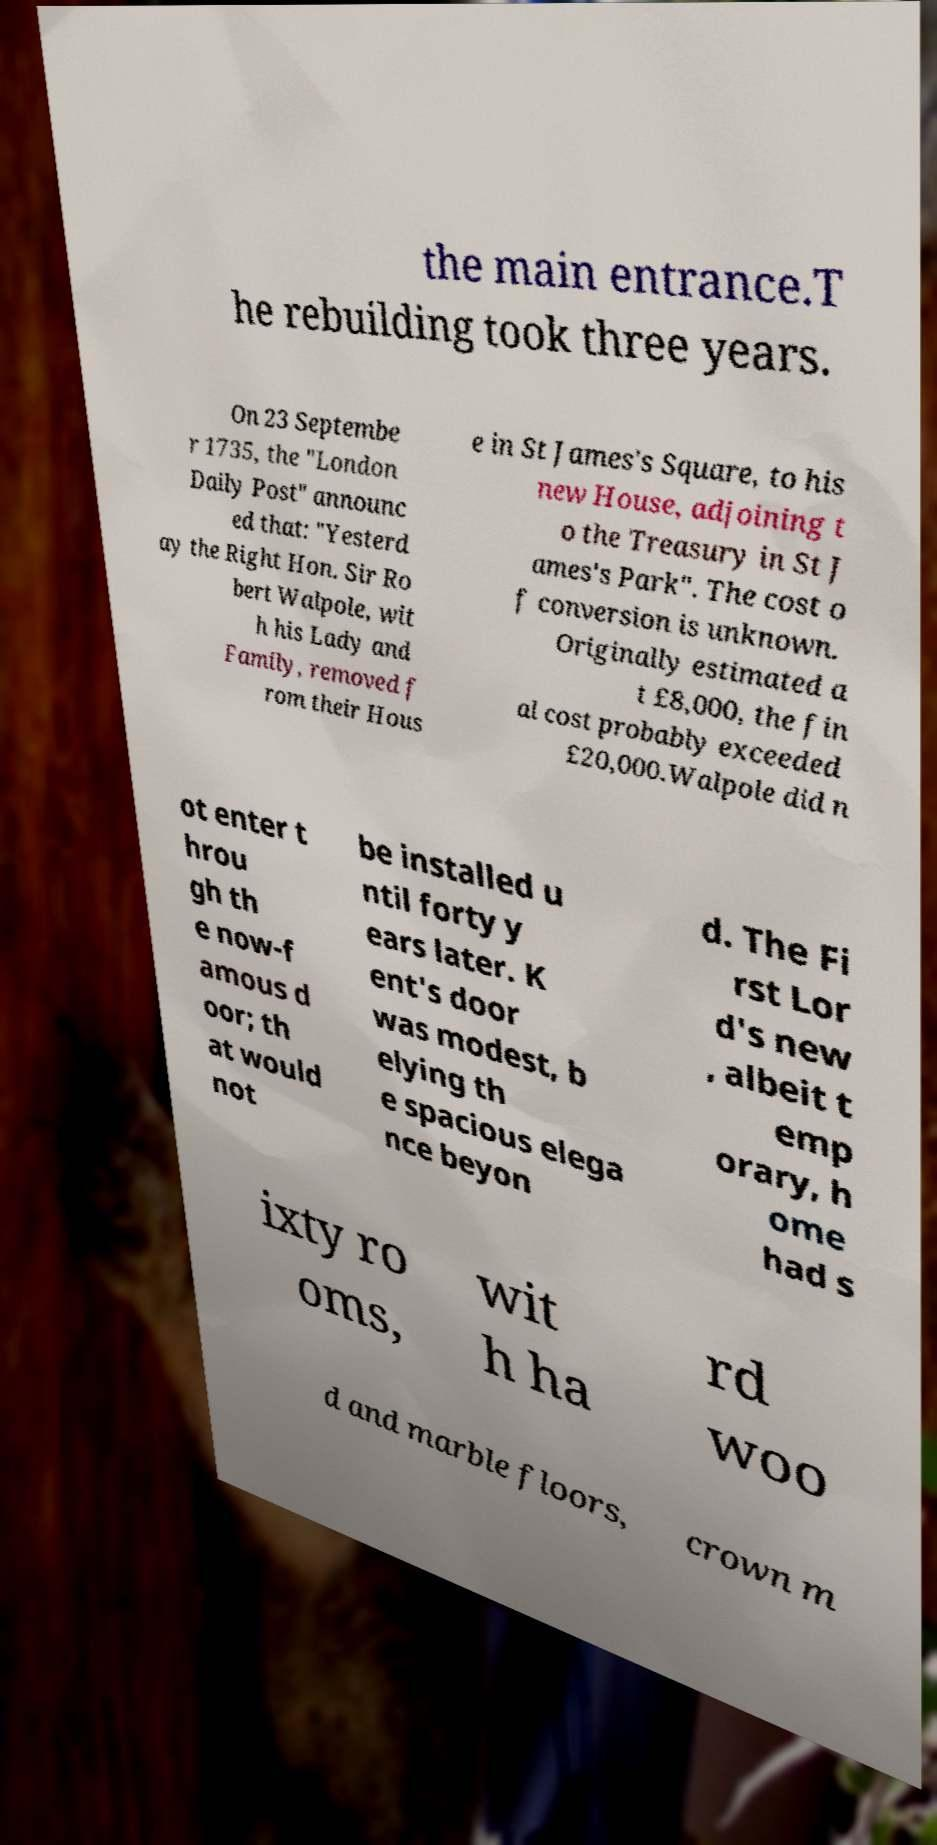Could you extract and type out the text from this image? the main entrance.T he rebuilding took three years. On 23 Septembe r 1735, the "London Daily Post" announc ed that: "Yesterd ay the Right Hon. Sir Ro bert Walpole, wit h his Lady and Family, removed f rom their Hous e in St James's Square, to his new House, adjoining t o the Treasury in St J ames's Park". The cost o f conversion is unknown. Originally estimated a t £8,000, the fin al cost probably exceeded £20,000.Walpole did n ot enter t hrou gh th e now-f amous d oor; th at would not be installed u ntil forty y ears later. K ent's door was modest, b elying th e spacious elega nce beyon d. The Fi rst Lor d's new , albeit t emp orary, h ome had s ixty ro oms, wit h ha rd woo d and marble floors, crown m 